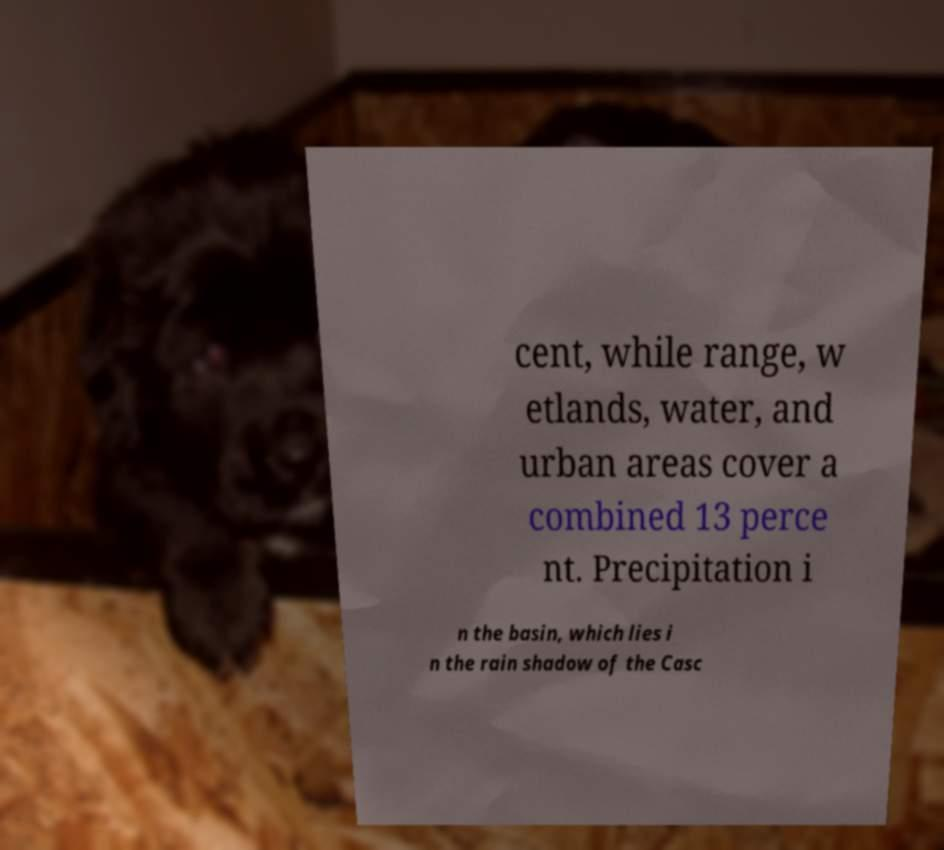Can you accurately transcribe the text from the provided image for me? cent, while range, w etlands, water, and urban areas cover a combined 13 perce nt. Precipitation i n the basin, which lies i n the rain shadow of the Casc 